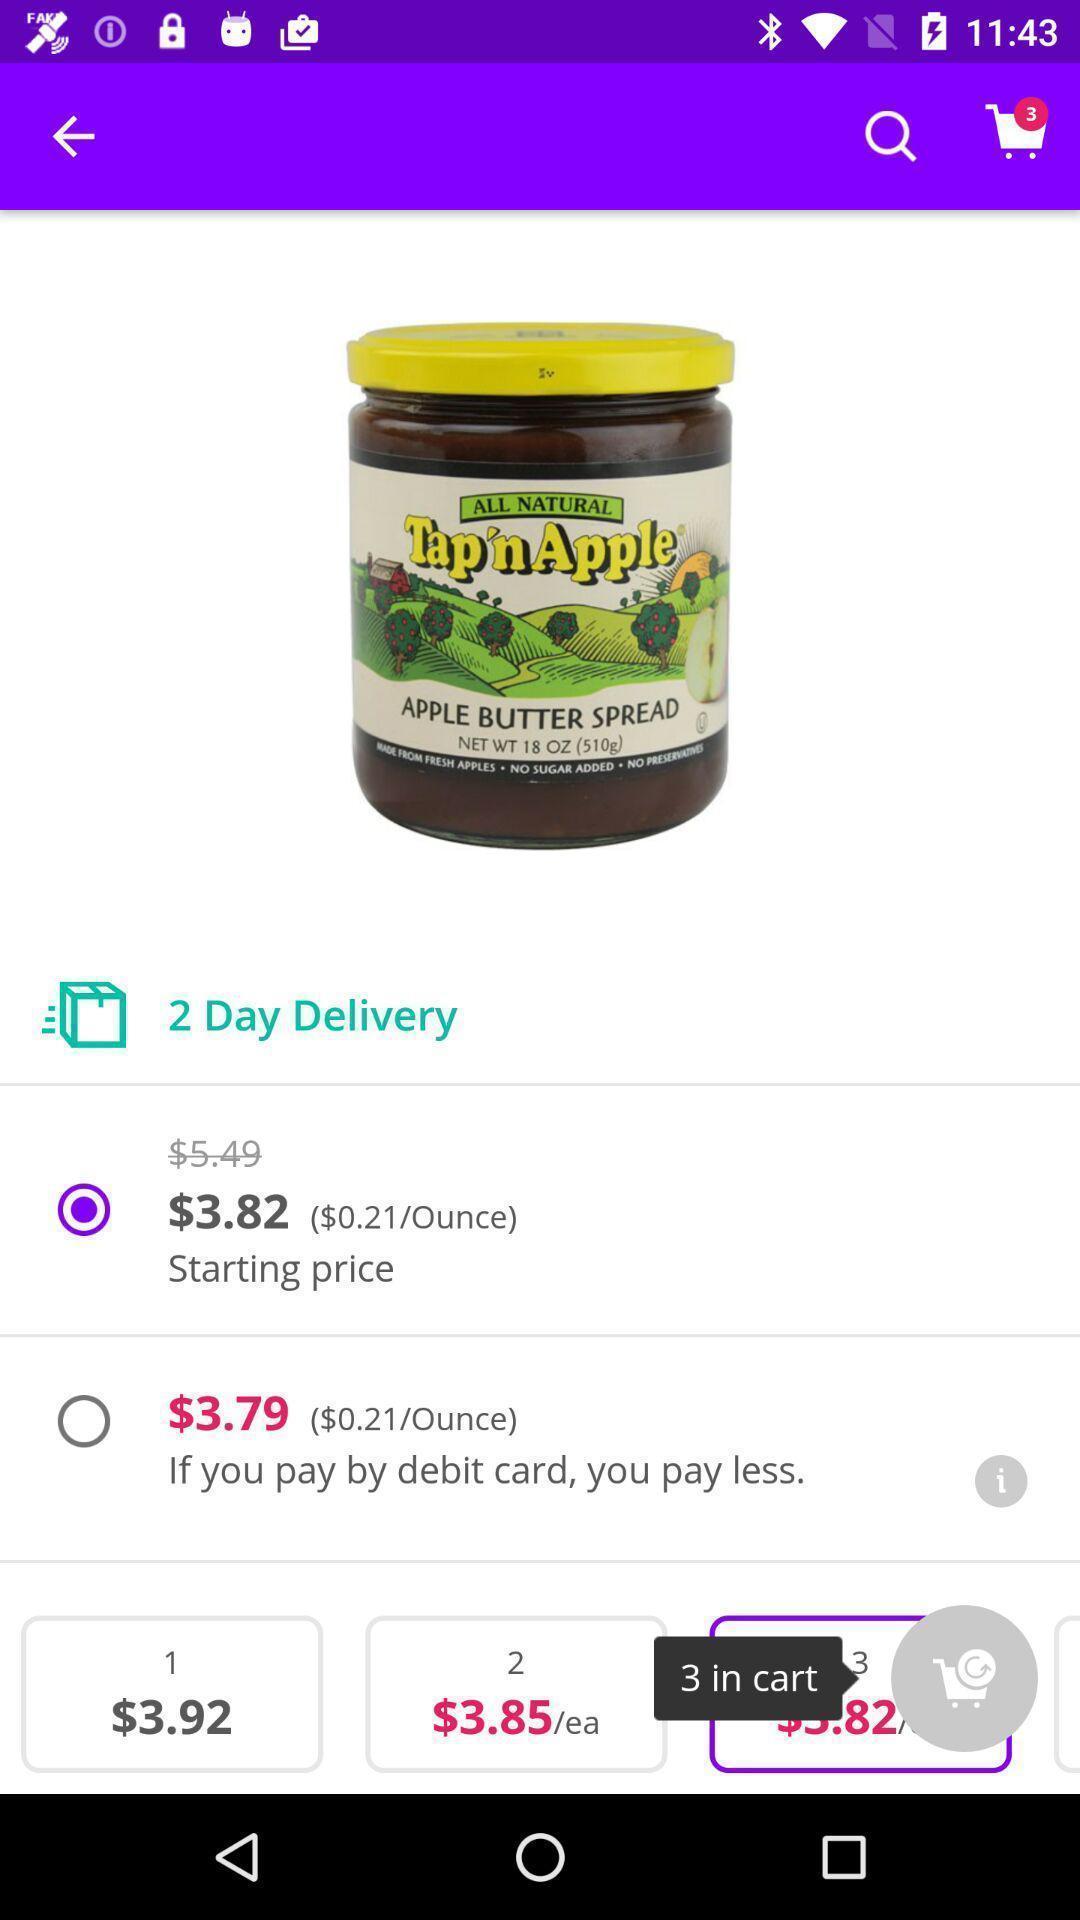Provide a textual representation of this image. Screen page of a shopping app. 